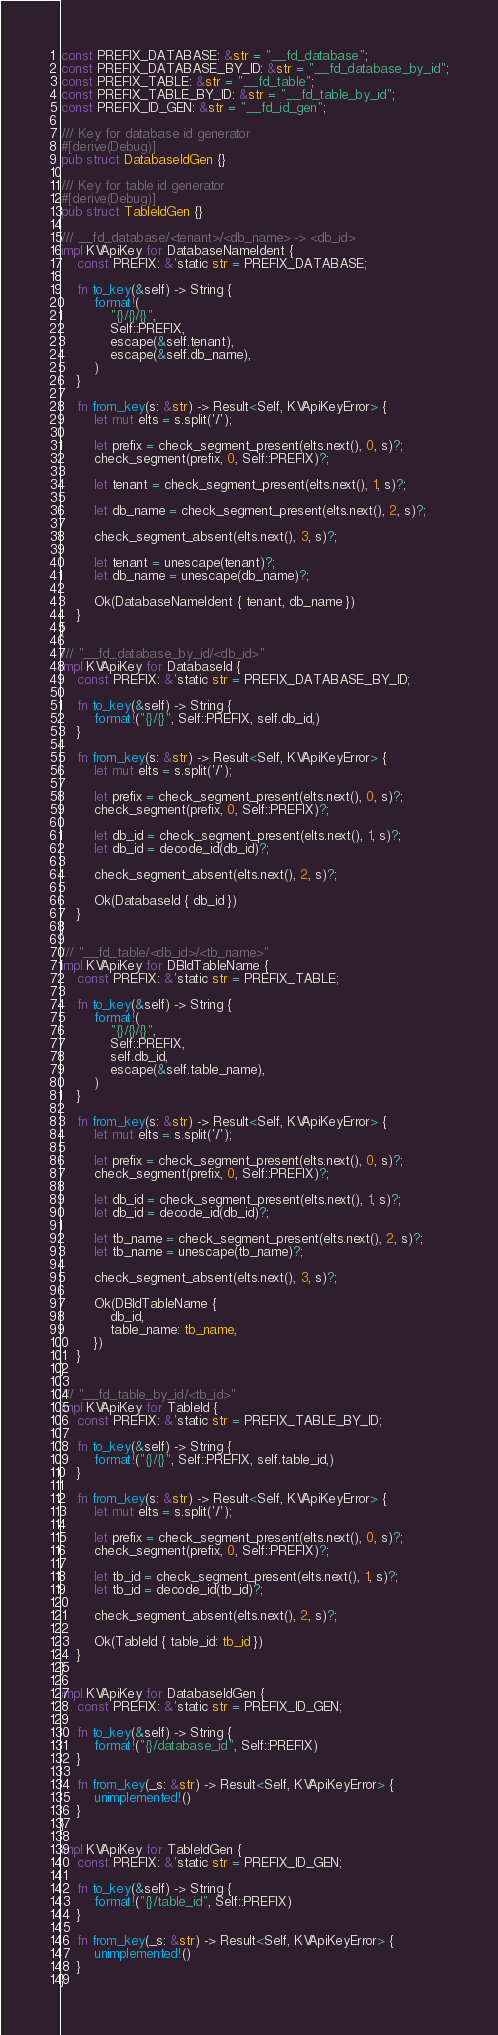<code> <loc_0><loc_0><loc_500><loc_500><_Rust_>const PREFIX_DATABASE: &str = "__fd_database";
const PREFIX_DATABASE_BY_ID: &str = "__fd_database_by_id";
const PREFIX_TABLE: &str = "__fd_table";
const PREFIX_TABLE_BY_ID: &str = "__fd_table_by_id";
const PREFIX_ID_GEN: &str = "__fd_id_gen";

/// Key for database id generator
#[derive(Debug)]
pub struct DatabaseIdGen {}

/// Key for table id generator
#[derive(Debug)]
pub struct TableIdGen {}

/// __fd_database/<tenant>/<db_name> -> <db_id>
impl KVApiKey for DatabaseNameIdent {
    const PREFIX: &'static str = PREFIX_DATABASE;

    fn to_key(&self) -> String {
        format!(
            "{}/{}/{}",
            Self::PREFIX,
            escape(&self.tenant),
            escape(&self.db_name),
        )
    }

    fn from_key(s: &str) -> Result<Self, KVApiKeyError> {
        let mut elts = s.split('/');

        let prefix = check_segment_present(elts.next(), 0, s)?;
        check_segment(prefix, 0, Self::PREFIX)?;

        let tenant = check_segment_present(elts.next(), 1, s)?;

        let db_name = check_segment_present(elts.next(), 2, s)?;

        check_segment_absent(elts.next(), 3, s)?;

        let tenant = unescape(tenant)?;
        let db_name = unescape(db_name)?;

        Ok(DatabaseNameIdent { tenant, db_name })
    }
}

/// "__fd_database_by_id/<db_id>"
impl KVApiKey for DatabaseId {
    const PREFIX: &'static str = PREFIX_DATABASE_BY_ID;

    fn to_key(&self) -> String {
        format!("{}/{}", Self::PREFIX, self.db_id,)
    }

    fn from_key(s: &str) -> Result<Self, KVApiKeyError> {
        let mut elts = s.split('/');

        let prefix = check_segment_present(elts.next(), 0, s)?;
        check_segment(prefix, 0, Self::PREFIX)?;

        let db_id = check_segment_present(elts.next(), 1, s)?;
        let db_id = decode_id(db_id)?;

        check_segment_absent(elts.next(), 2, s)?;

        Ok(DatabaseId { db_id })
    }
}

/// "__fd_table/<db_id>/<tb_name>"
impl KVApiKey for DBIdTableName {
    const PREFIX: &'static str = PREFIX_TABLE;

    fn to_key(&self) -> String {
        format!(
            "{}/{}/{}",
            Self::PREFIX,
            self.db_id,
            escape(&self.table_name),
        )
    }

    fn from_key(s: &str) -> Result<Self, KVApiKeyError> {
        let mut elts = s.split('/');

        let prefix = check_segment_present(elts.next(), 0, s)?;
        check_segment(prefix, 0, Self::PREFIX)?;

        let db_id = check_segment_present(elts.next(), 1, s)?;
        let db_id = decode_id(db_id)?;

        let tb_name = check_segment_present(elts.next(), 2, s)?;
        let tb_name = unescape(tb_name)?;

        check_segment_absent(elts.next(), 3, s)?;

        Ok(DBIdTableName {
            db_id,
            table_name: tb_name,
        })
    }
}

/// "__fd_table_by_id/<tb_id>"
impl KVApiKey for TableId {
    const PREFIX: &'static str = PREFIX_TABLE_BY_ID;

    fn to_key(&self) -> String {
        format!("{}/{}", Self::PREFIX, self.table_id,)
    }

    fn from_key(s: &str) -> Result<Self, KVApiKeyError> {
        let mut elts = s.split('/');

        let prefix = check_segment_present(elts.next(), 0, s)?;
        check_segment(prefix, 0, Self::PREFIX)?;

        let tb_id = check_segment_present(elts.next(), 1, s)?;
        let tb_id = decode_id(tb_id)?;

        check_segment_absent(elts.next(), 2, s)?;

        Ok(TableId { table_id: tb_id })
    }
}

impl KVApiKey for DatabaseIdGen {
    const PREFIX: &'static str = PREFIX_ID_GEN;

    fn to_key(&self) -> String {
        format!("{}/database_id", Self::PREFIX)
    }

    fn from_key(_s: &str) -> Result<Self, KVApiKeyError> {
        unimplemented!()
    }
}

impl KVApiKey for TableIdGen {
    const PREFIX: &'static str = PREFIX_ID_GEN;

    fn to_key(&self) -> String {
        format!("{}/table_id", Self::PREFIX)
    }

    fn from_key(_s: &str) -> Result<Self, KVApiKeyError> {
        unimplemented!()
    }
}
</code> 